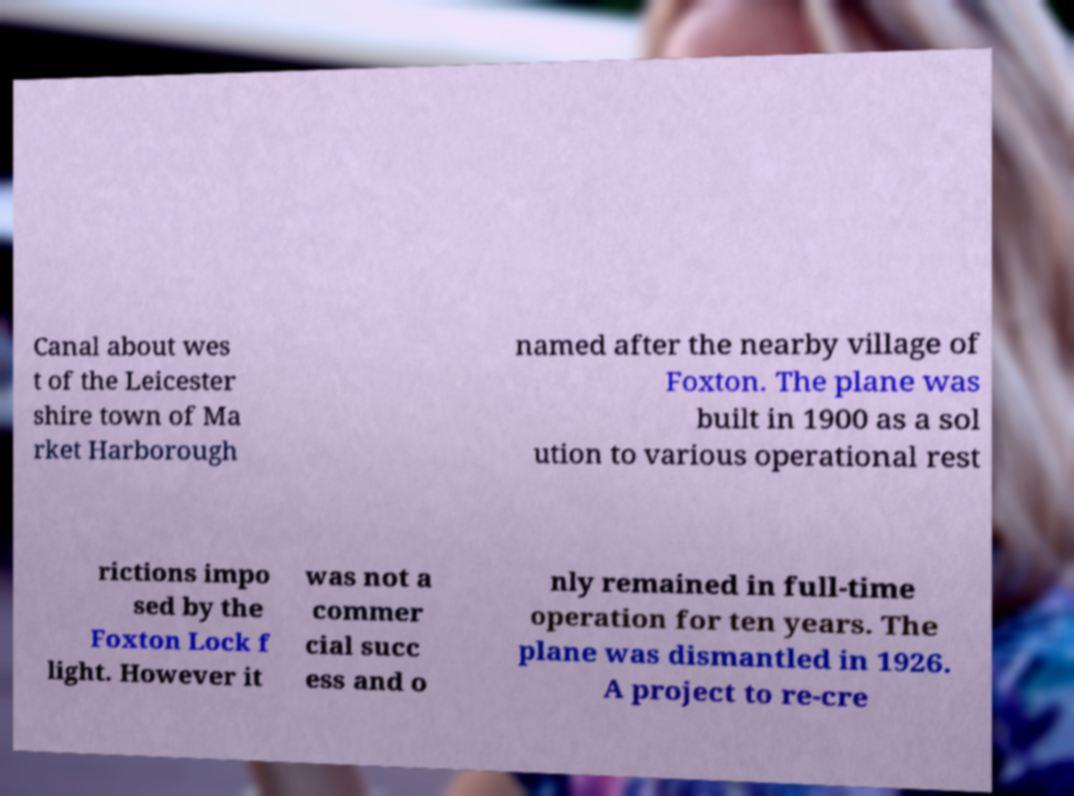Could you extract and type out the text from this image? Canal about wes t of the Leicester shire town of Ma rket Harborough named after the nearby village of Foxton. The plane was built in 1900 as a sol ution to various operational rest rictions impo sed by the Foxton Lock f light. However it was not a commer cial succ ess and o nly remained in full-time operation for ten years. The plane was dismantled in 1926. A project to re-cre 